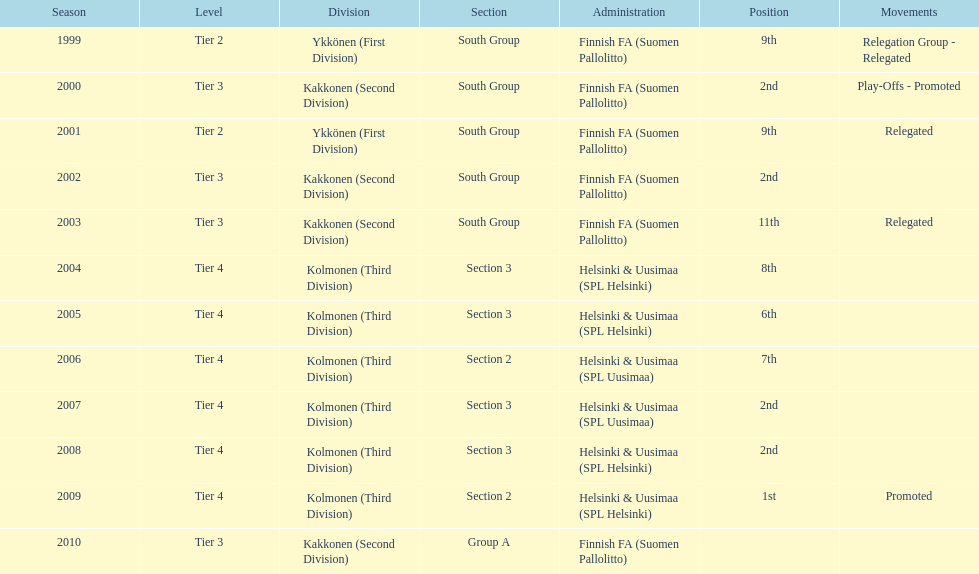How many tiers had more than one relegated movement? 1. 